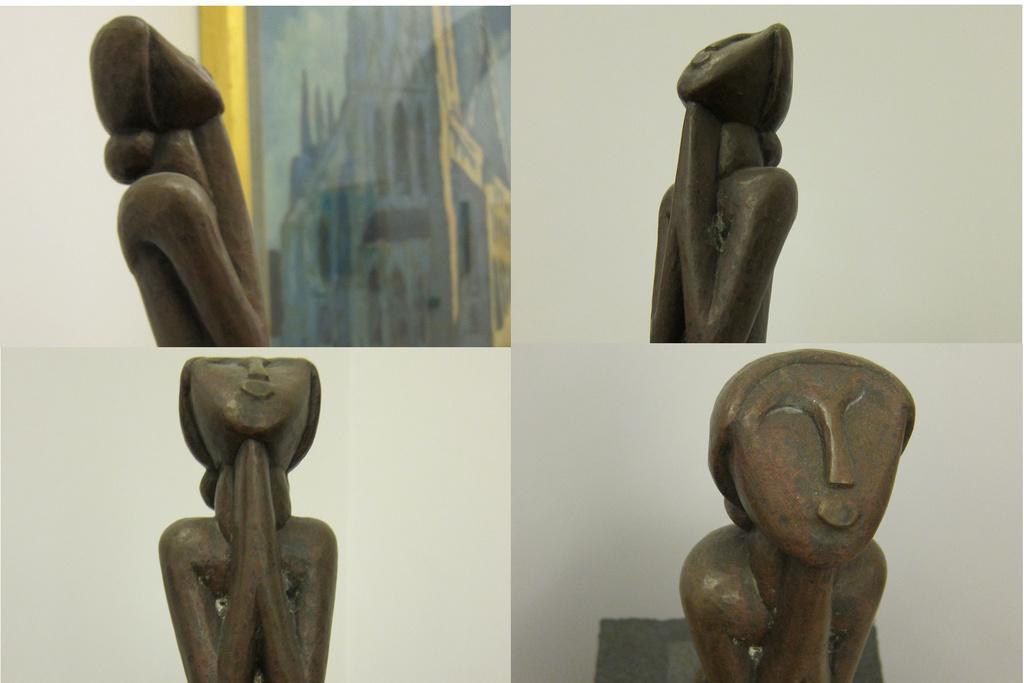Describe this image in one or two sentences. This is a collage in this image there are some sculptures and in the background there is a wall, on the left side there is one photo frame on the wall. 